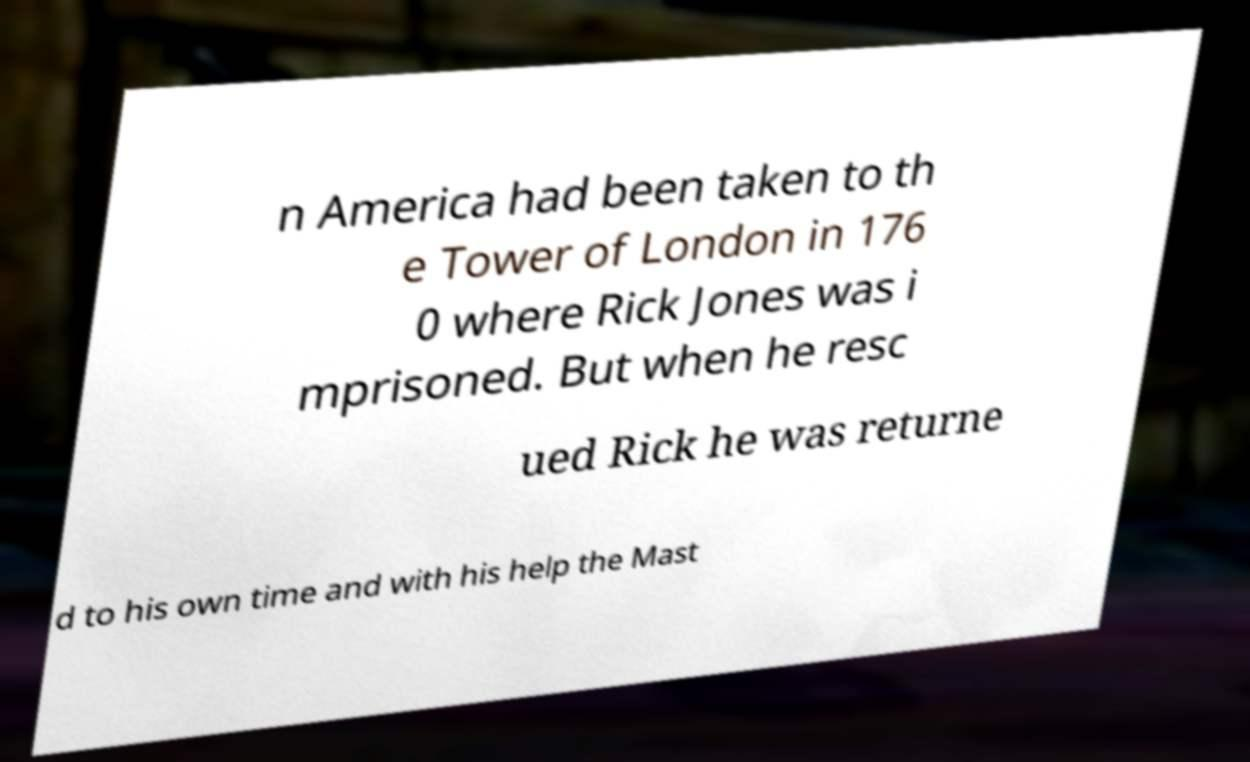Can you read and provide the text displayed in the image?This photo seems to have some interesting text. Can you extract and type it out for me? n America had been taken to th e Tower of London in 176 0 where Rick Jones was i mprisoned. But when he resc ued Rick he was returne d to his own time and with his help the Mast 